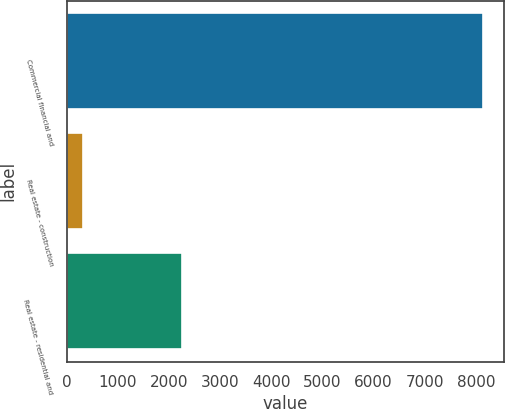Convert chart. <chart><loc_0><loc_0><loc_500><loc_500><bar_chart><fcel>Commercial financial and<fcel>Real estate - construction<fcel>Real estate - residential and<nl><fcel>8145<fcel>321<fcel>2247<nl></chart> 